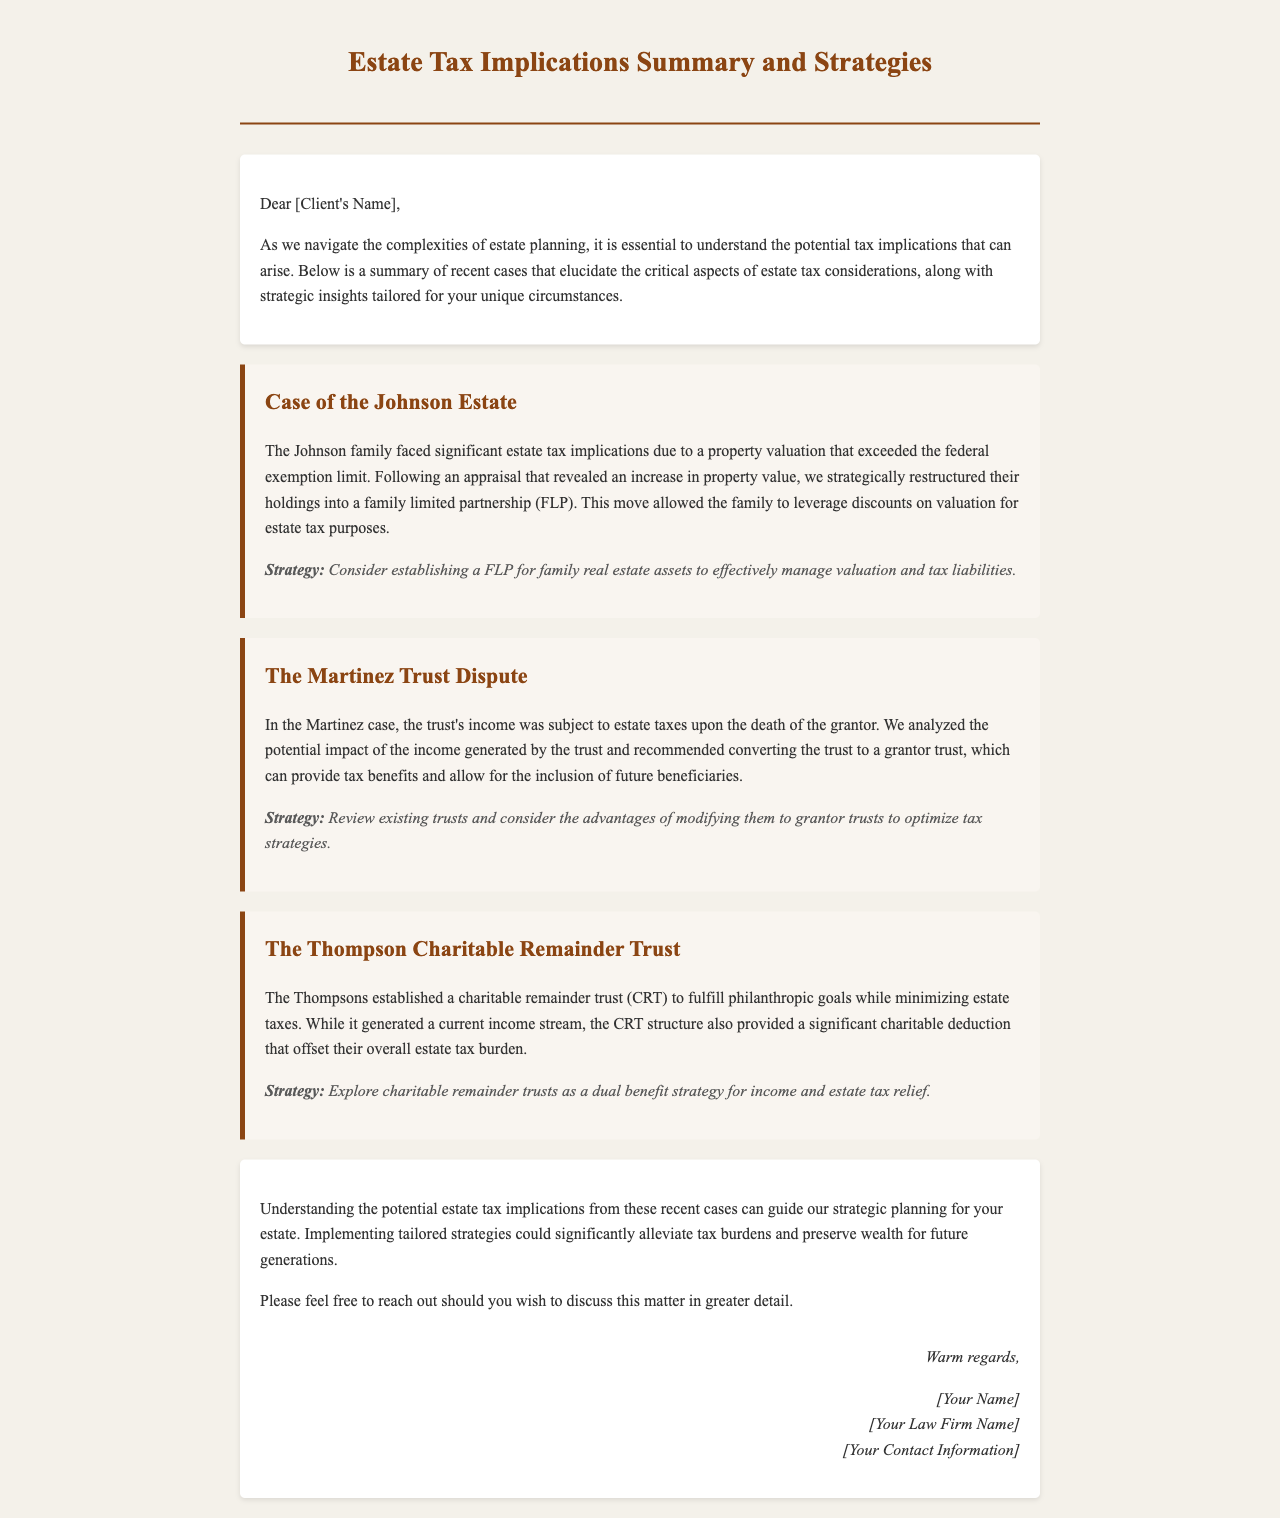What was the main issue faced by the Johnson family? The main issue faced by the Johnson family was significant estate tax implications due to a property valuation that exceeded the federal exemption limit.
Answer: property valuation What strategy was recommended for the Johnson Estate? The recommended strategy for the Johnson Estate was to establish a family limited partnership (FLP) for family real estate assets.
Answer: establish a FLP What type of trust was discussed in the Martinez case? The type of trust discussed in the Martinez case was a grantor trust.
Answer: grantor trust What benefit did the Thompsons achieve through their charitable remainder trust? The benefit achieved through the charitable remainder trust was a significant charitable deduction that offset their overall estate tax burden.
Answer: charitable deduction How many cases are summarized in the document? The document summarizes three cases: Johnson Estate, Martinez Trust Dispute, and Thompson Charitable Remainder Trust.
Answer: three cases What is the overall purpose of the document? The overall purpose of the document is to summarize estate tax implications and recommend strategies.
Answer: summarize estate tax implications Who is the intended recipient of this document? The intended recipient of this document is [Client's Name].
Answer: [Client's Name] What is the primary subject matter of this document? The primary subject matter of this document is estate tax implications summary and strategies.
Answer: estate tax implications 